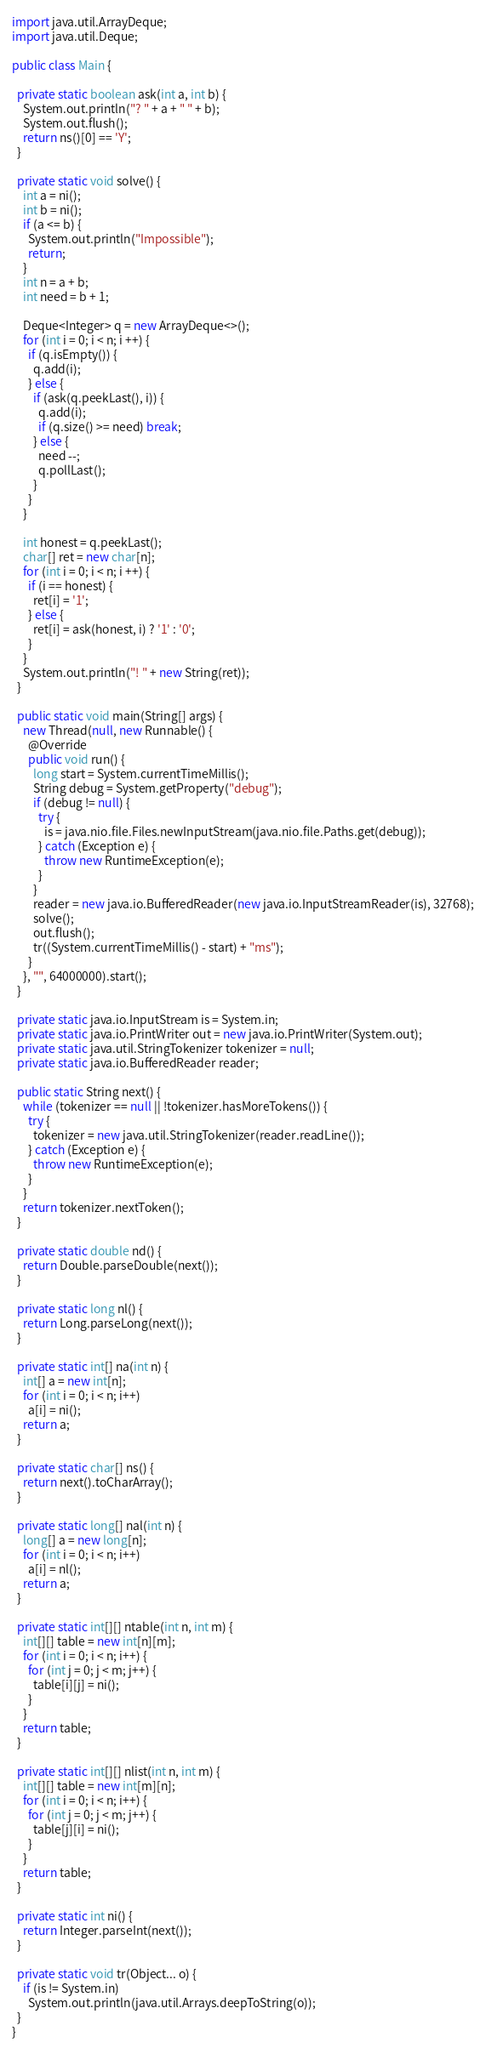<code> <loc_0><loc_0><loc_500><loc_500><_Java_>
import java.util.ArrayDeque;
import java.util.Deque;

public class Main {

  private static boolean ask(int a, int b) {
    System.out.println("? " + a + " " + b);
    System.out.flush();
    return ns()[0] == 'Y';
  }

  private static void solve() {
    int a = ni();
    int b = ni();
    if (a <= b) {
      System.out.println("Impossible");
      return;
    }
    int n = a + b;
    int need = b + 1;

    Deque<Integer> q = new ArrayDeque<>();
    for (int i = 0; i < n; i ++) {
      if (q.isEmpty()) {
        q.add(i);
      } else {
        if (ask(q.peekLast(), i)) {
          q.add(i);
          if (q.size() >= need) break;
        } else {
          need --;
          q.pollLast();
        }
      }
    }
    
    int honest = q.peekLast();
    char[] ret = new char[n];
    for (int i = 0; i < n; i ++) {
      if (i == honest) {
        ret[i] = '1';
      } else {
        ret[i] = ask(honest, i) ? '1' : '0';
      }
    }
    System.out.println("! " + new String(ret));
  }

  public static void main(String[] args) {
    new Thread(null, new Runnable() {
      @Override
      public void run() {
        long start = System.currentTimeMillis();
        String debug = System.getProperty("debug");
        if (debug != null) {
          try {
            is = java.nio.file.Files.newInputStream(java.nio.file.Paths.get(debug));
          } catch (Exception e) {
            throw new RuntimeException(e);
          }
        }
        reader = new java.io.BufferedReader(new java.io.InputStreamReader(is), 32768);
        solve();
        out.flush();
        tr((System.currentTimeMillis() - start) + "ms");
      }
    }, "", 64000000).start();
  }

  private static java.io.InputStream is = System.in;
  private static java.io.PrintWriter out = new java.io.PrintWriter(System.out);
  private static java.util.StringTokenizer tokenizer = null;
  private static java.io.BufferedReader reader;

  public static String next() {
    while (tokenizer == null || !tokenizer.hasMoreTokens()) {
      try {
        tokenizer = new java.util.StringTokenizer(reader.readLine());
      } catch (Exception e) {
        throw new RuntimeException(e);
      }
    }
    return tokenizer.nextToken();
  }

  private static double nd() {
    return Double.parseDouble(next());
  }

  private static long nl() {
    return Long.parseLong(next());
  }

  private static int[] na(int n) {
    int[] a = new int[n];
    for (int i = 0; i < n; i++)
      a[i] = ni();
    return a;
  }

  private static char[] ns() {
    return next().toCharArray();
  }

  private static long[] nal(int n) {
    long[] a = new long[n];
    for (int i = 0; i < n; i++)
      a[i] = nl();
    return a;
  }

  private static int[][] ntable(int n, int m) {
    int[][] table = new int[n][m];
    for (int i = 0; i < n; i++) {
      for (int j = 0; j < m; j++) {
        table[i][j] = ni();
      }
    }
    return table;
  }

  private static int[][] nlist(int n, int m) {
    int[][] table = new int[m][n];
    for (int i = 0; i < n; i++) {
      for (int j = 0; j < m; j++) {
        table[j][i] = ni();
      }
    }
    return table;
  }

  private static int ni() {
    return Integer.parseInt(next());
  }

  private static void tr(Object... o) {
    if (is != System.in)
      System.out.println(java.util.Arrays.deepToString(o));
  }
}
</code> 